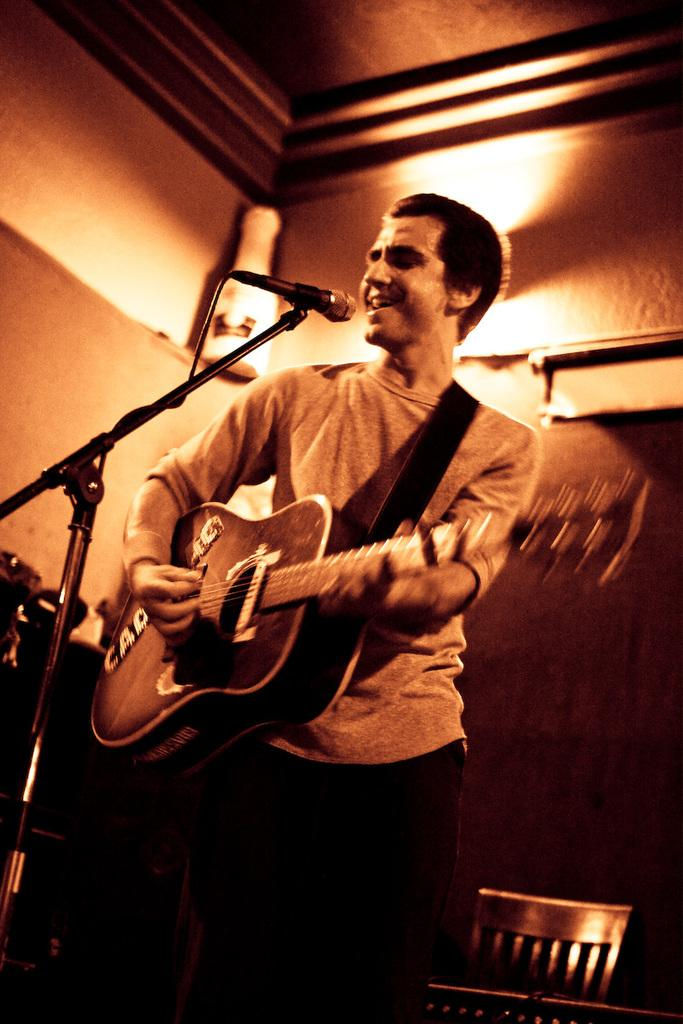What is the person in the image doing? The person is playing the guitar. What object is the person holding while playing the guitar? The person is holding a guitar. What is in front of the person that might be used for amplifying their voice? There is a microphone in front of the person. What can be seen in the background of the image? There are lights and a wall visible in the background. What type of caption is written on the wall in the image? There is no caption visible on the wall in the image. How does the sleet affect the person's ability to play the guitar in the image? There is no sleet present in the image, so it does not affect the person's ability to play the guitar. 